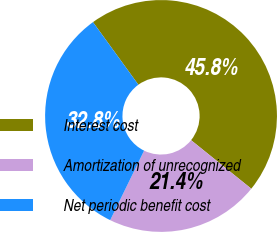Convert chart to OTSL. <chart><loc_0><loc_0><loc_500><loc_500><pie_chart><fcel>Interest cost<fcel>Amortization of unrecognized<fcel>Net periodic benefit cost<nl><fcel>45.78%<fcel>21.43%<fcel>32.79%<nl></chart> 